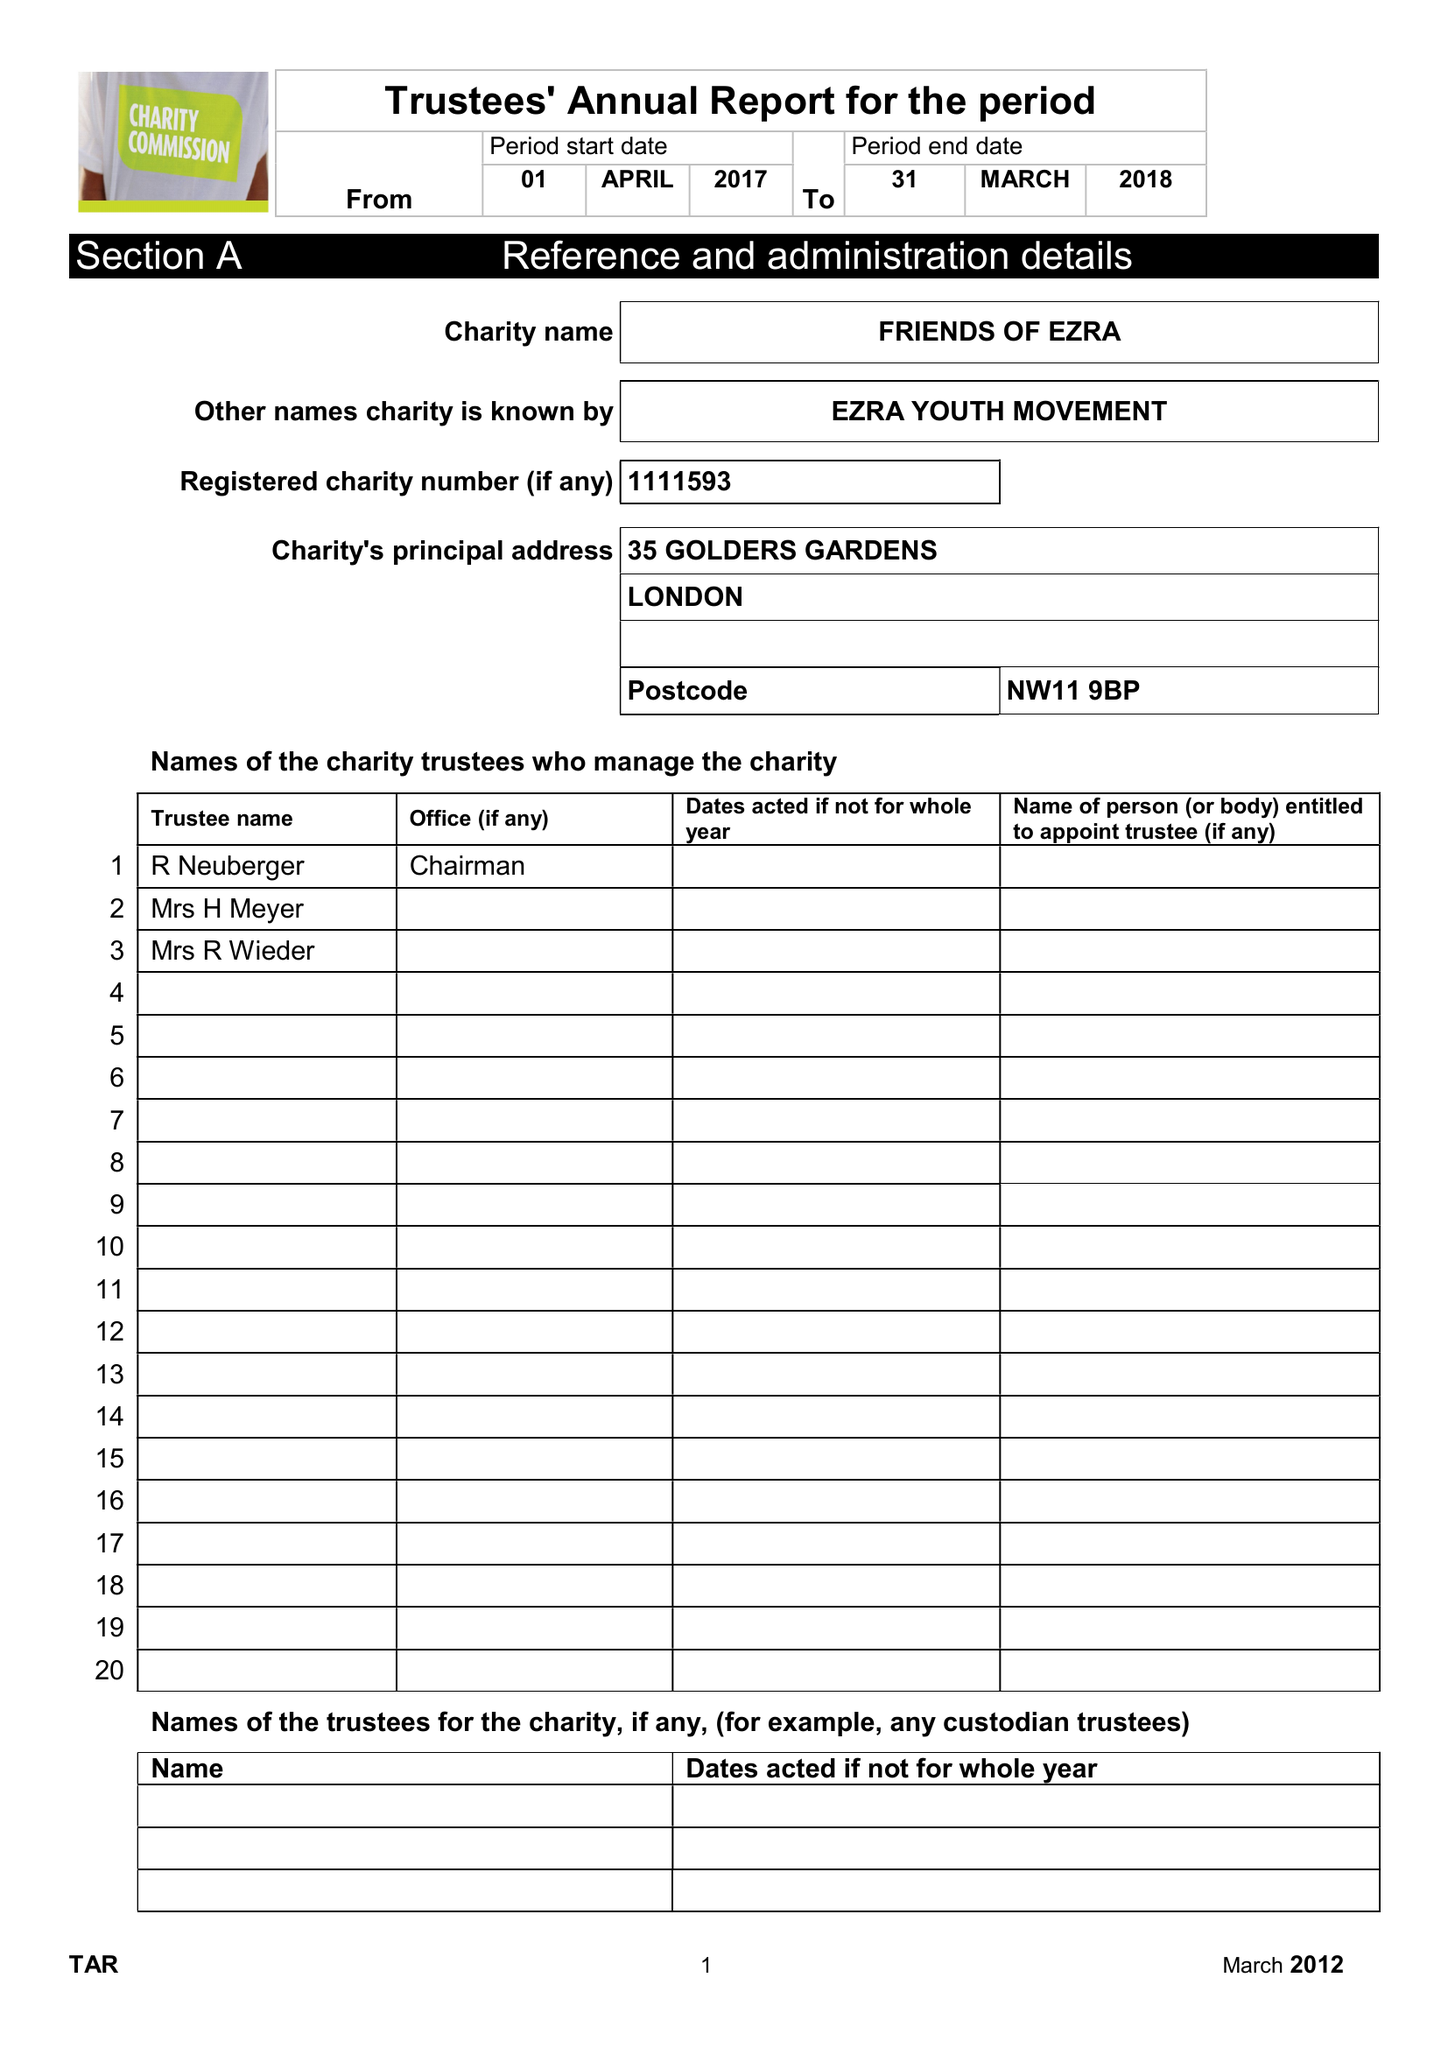What is the value for the income_annually_in_british_pounds?
Answer the question using a single word or phrase. 329445.00 